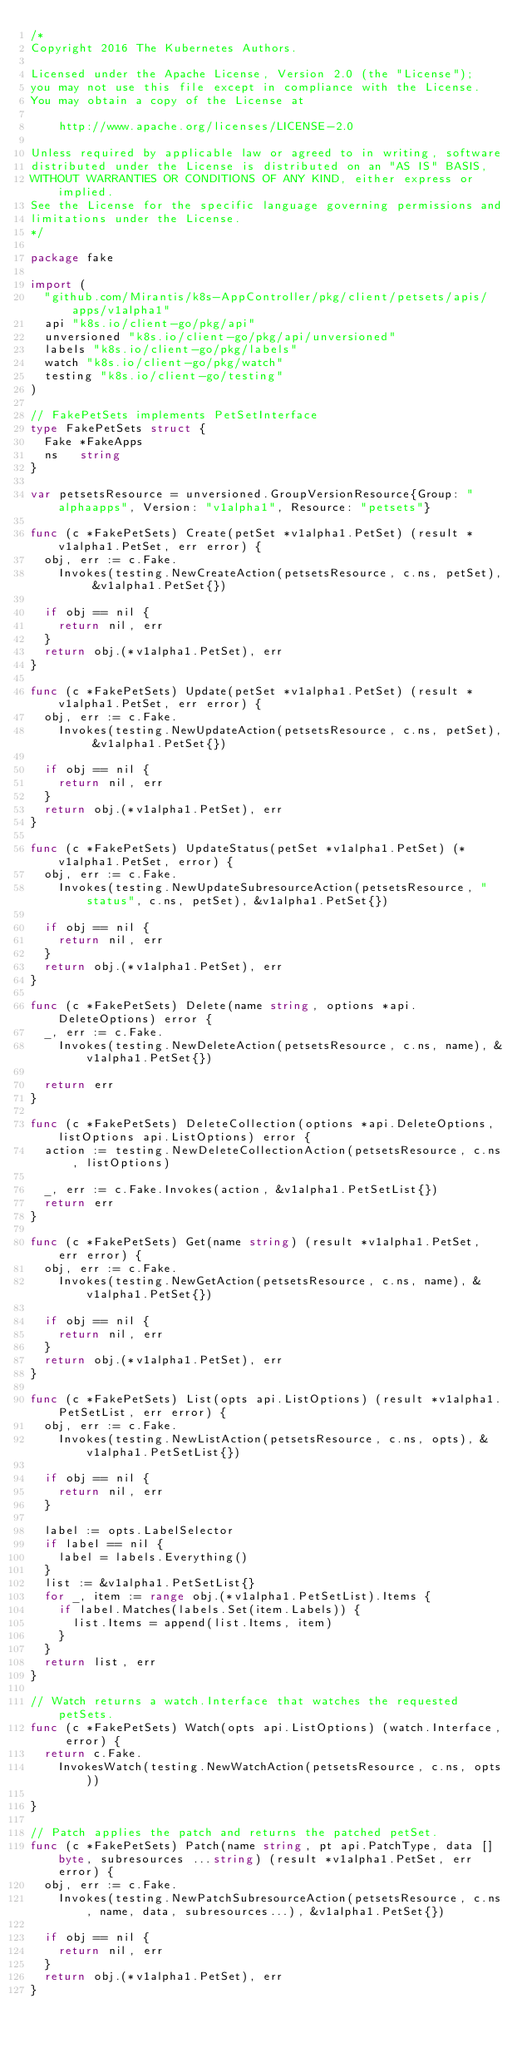Convert code to text. <code><loc_0><loc_0><loc_500><loc_500><_Go_>/*
Copyright 2016 The Kubernetes Authors.

Licensed under the Apache License, Version 2.0 (the "License");
you may not use this file except in compliance with the License.
You may obtain a copy of the License at

    http://www.apache.org/licenses/LICENSE-2.0

Unless required by applicable law or agreed to in writing, software
distributed under the License is distributed on an "AS IS" BASIS,
WITHOUT WARRANTIES OR CONDITIONS OF ANY KIND, either express or implied.
See the License for the specific language governing permissions and
limitations under the License.
*/

package fake

import (
	"github.com/Mirantis/k8s-AppController/pkg/client/petsets/apis/apps/v1alpha1"
	api "k8s.io/client-go/pkg/api"
	unversioned "k8s.io/client-go/pkg/api/unversioned"
	labels "k8s.io/client-go/pkg/labels"
	watch "k8s.io/client-go/pkg/watch"
	testing "k8s.io/client-go/testing"
)

// FakePetSets implements PetSetInterface
type FakePetSets struct {
	Fake *FakeApps
	ns   string
}

var petsetsResource = unversioned.GroupVersionResource{Group: "alphaapps", Version: "v1alpha1", Resource: "petsets"}

func (c *FakePetSets) Create(petSet *v1alpha1.PetSet) (result *v1alpha1.PetSet, err error) {
	obj, err := c.Fake.
		Invokes(testing.NewCreateAction(petsetsResource, c.ns, petSet), &v1alpha1.PetSet{})

	if obj == nil {
		return nil, err
	}
	return obj.(*v1alpha1.PetSet), err
}

func (c *FakePetSets) Update(petSet *v1alpha1.PetSet) (result *v1alpha1.PetSet, err error) {
	obj, err := c.Fake.
		Invokes(testing.NewUpdateAction(petsetsResource, c.ns, petSet), &v1alpha1.PetSet{})

	if obj == nil {
		return nil, err
	}
	return obj.(*v1alpha1.PetSet), err
}

func (c *FakePetSets) UpdateStatus(petSet *v1alpha1.PetSet) (*v1alpha1.PetSet, error) {
	obj, err := c.Fake.
		Invokes(testing.NewUpdateSubresourceAction(petsetsResource, "status", c.ns, petSet), &v1alpha1.PetSet{})

	if obj == nil {
		return nil, err
	}
	return obj.(*v1alpha1.PetSet), err
}

func (c *FakePetSets) Delete(name string, options *api.DeleteOptions) error {
	_, err := c.Fake.
		Invokes(testing.NewDeleteAction(petsetsResource, c.ns, name), &v1alpha1.PetSet{})

	return err
}

func (c *FakePetSets) DeleteCollection(options *api.DeleteOptions, listOptions api.ListOptions) error {
	action := testing.NewDeleteCollectionAction(petsetsResource, c.ns, listOptions)

	_, err := c.Fake.Invokes(action, &v1alpha1.PetSetList{})
	return err
}

func (c *FakePetSets) Get(name string) (result *v1alpha1.PetSet, err error) {
	obj, err := c.Fake.
		Invokes(testing.NewGetAction(petsetsResource, c.ns, name), &v1alpha1.PetSet{})

	if obj == nil {
		return nil, err
	}
	return obj.(*v1alpha1.PetSet), err
}

func (c *FakePetSets) List(opts api.ListOptions) (result *v1alpha1.PetSetList, err error) {
	obj, err := c.Fake.
		Invokes(testing.NewListAction(petsetsResource, c.ns, opts), &v1alpha1.PetSetList{})

	if obj == nil {
		return nil, err
	}

	label := opts.LabelSelector
	if label == nil {
		label = labels.Everything()
	}
	list := &v1alpha1.PetSetList{}
	for _, item := range obj.(*v1alpha1.PetSetList).Items {
		if label.Matches(labels.Set(item.Labels)) {
			list.Items = append(list.Items, item)
		}
	}
	return list, err
}

// Watch returns a watch.Interface that watches the requested petSets.
func (c *FakePetSets) Watch(opts api.ListOptions) (watch.Interface, error) {
	return c.Fake.
		InvokesWatch(testing.NewWatchAction(petsetsResource, c.ns, opts))

}

// Patch applies the patch and returns the patched petSet.
func (c *FakePetSets) Patch(name string, pt api.PatchType, data []byte, subresources ...string) (result *v1alpha1.PetSet, err error) {
	obj, err := c.Fake.
		Invokes(testing.NewPatchSubresourceAction(petsetsResource, c.ns, name, data, subresources...), &v1alpha1.PetSet{})

	if obj == nil {
		return nil, err
	}
	return obj.(*v1alpha1.PetSet), err
}
</code> 